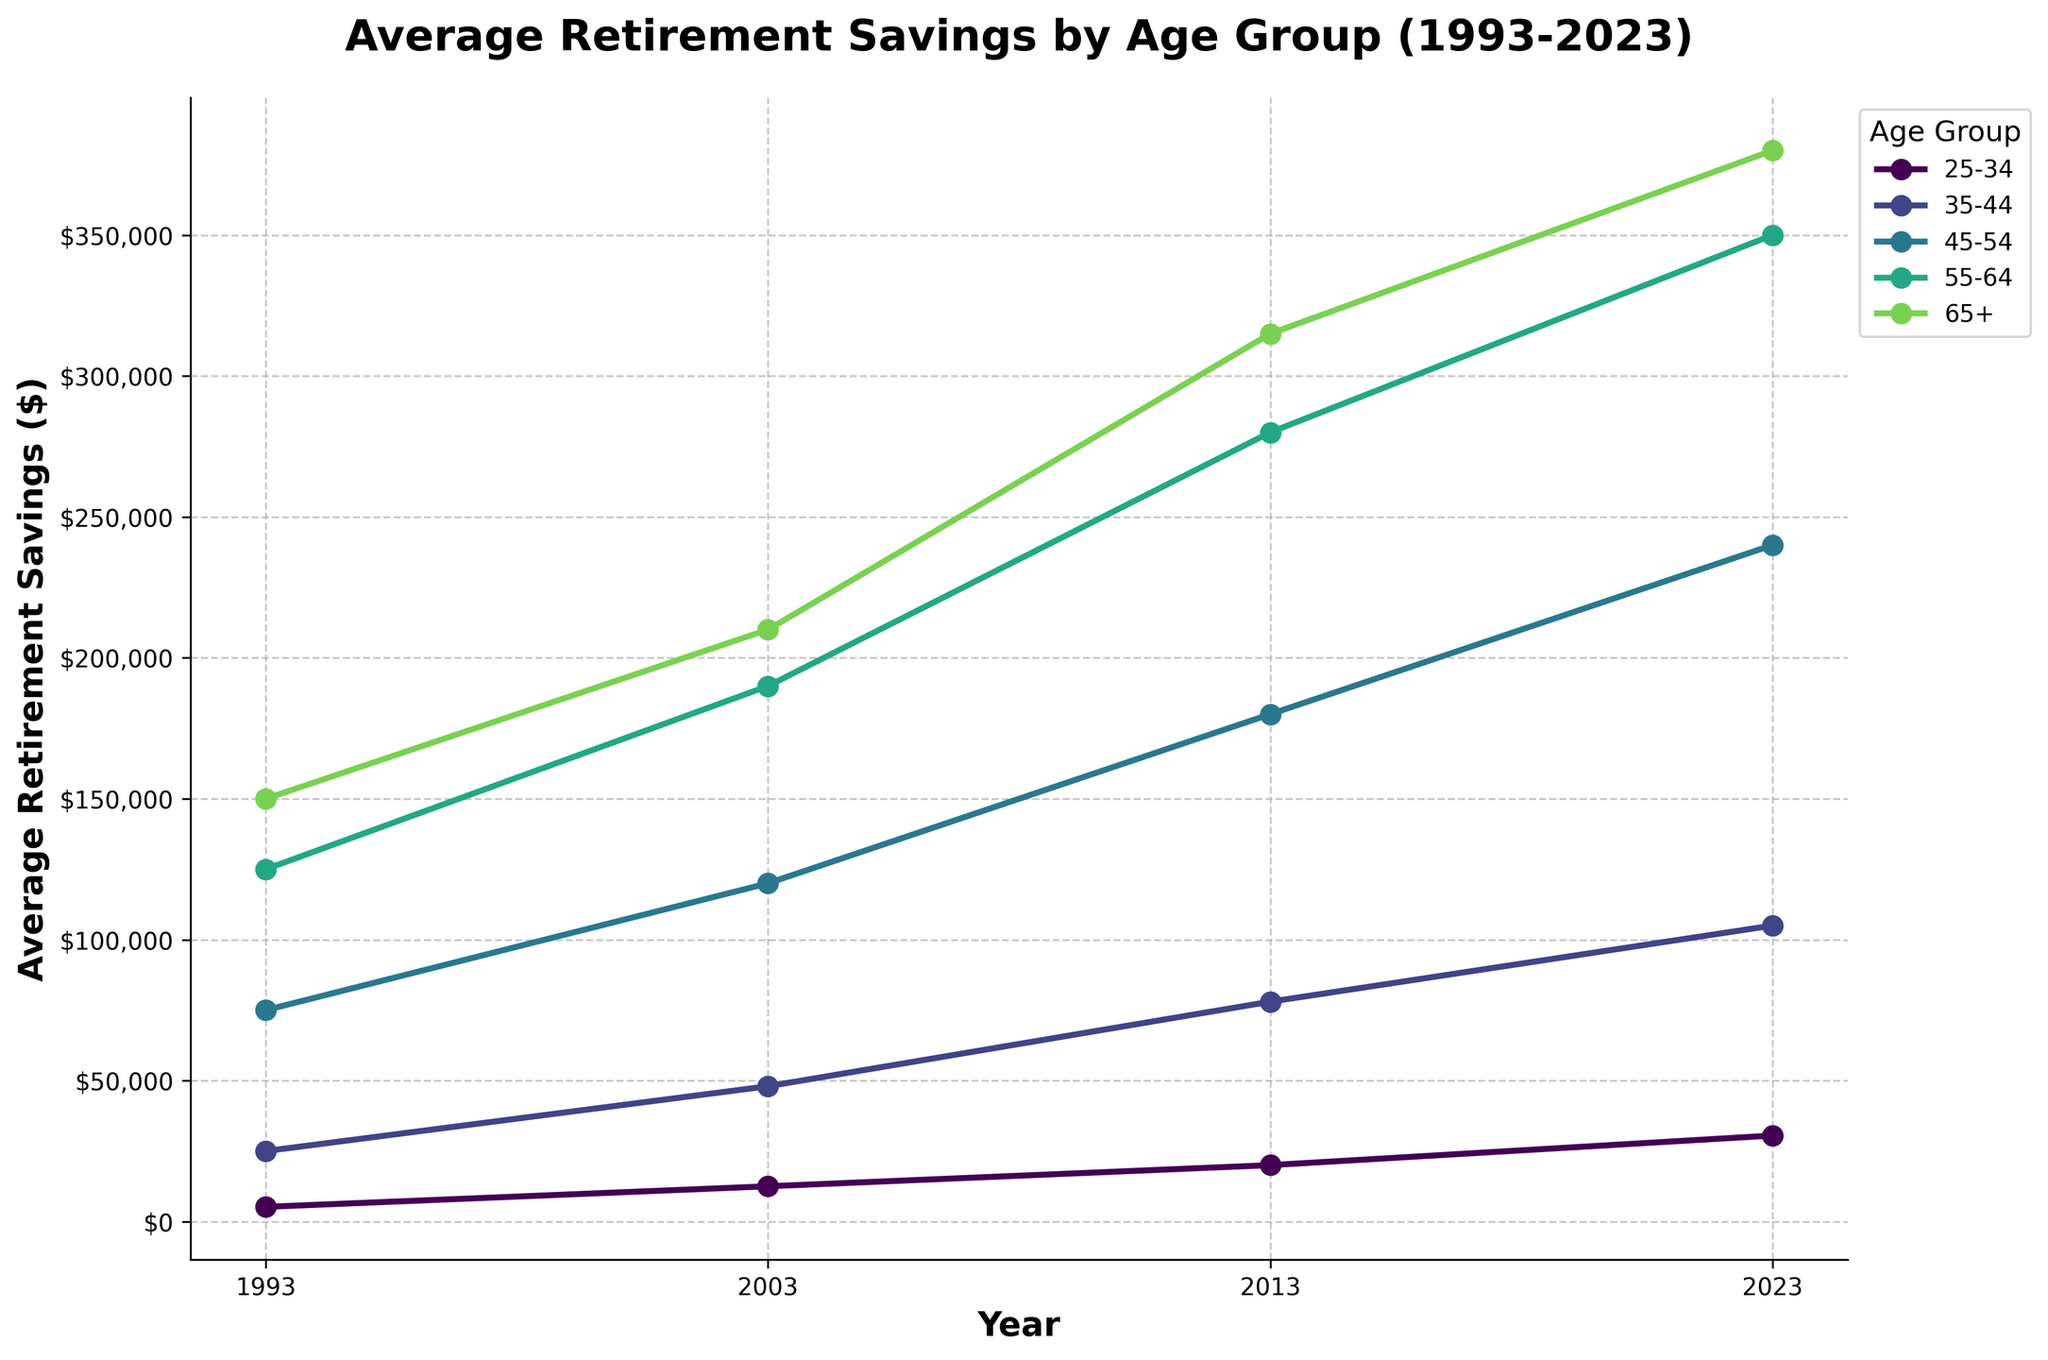What is the average retirement savings for the 55-64 age group in 2023? First, locate the 55-64 age group's data in 2023, which is represented by a point on the line chart. According to the table, this value is $350,000.
Answer: $350,000 Which age group had the highest average retirement savings in 1993? Check the 1993 data points for all age groups. The 65+ age group has the highest value of $150,000 among them.
Answer: 65+ What is the difference in average retirement savings for the 45-54 age group between 1993 and 2023? Identify the data points for the 45-54 age group in 1993 and 2023: $75,000 and $240,000 respectively. Calculate the difference: $240,000 - $75,000 = $165,000.
Answer: $165,000 Which age group shows the highest percentage increase in average savings from 1993 to 2023? Calculate the percentage increase for each age group using the formula: ((Value in 2023 - Value in 1993) / Value in 1993) * 100. The 25-34 age group shows ((30,500 - 5,200) / 5,200) * 100 = 486.54%.
Answer: 25-34 What is the trend of average retirement savings for the 35-44 age group from 1993 to 2023? Observe the line for the 35-44 age group from 1993 to 2023. The average retirement savings increase from $25,000 to $105,000. This indicates a consistent upward trend.
Answer: Upward Compare the average retirement savings of the 65+ age group in 2003 and 2023. Locate the 65+ age group data for 2003 and 2023, which are $210,000 and $380,000 respectively. 2023's savings are higher compared to 2003.
Answer: 2023 is higher By how much did average retirement savings for the 55-64 age group increase from 2003 to 2023? Find the values for the 55-64 age group in 2003 ($190,000) and in 2023 ($350,000). Subtract 2003 savings from 2023 savings: $350,000 - $190,000 = $160,000.
Answer: $160,000 Do younger age groups (25-34, 35-44) show a steeper increase in savings over the years compared to older ones (55-64, 65+)? Compare the slopes of the lines related to younger age groups with those of older age groups. Younger age groups like 25-34 and 35-44 have visibly steeper lines, indicating a faster rate of increase.
Answer: Yes What was the average retirement savings difference between the age groups 35-44 and 45-54 in 2013? Identify the 2013 data for 35-44 ($78,000) and 45-54 ($180,000), then subtract: $180,000 - $78,000 = $102,000.
Answer: $102,000 Which age group had the smallest absolute increase in average retirement savings from 1993 to 2023? Calculate the absolute increase for each age group. The smallest change is for the 65+ age group with $380,000 - $150,000 = $230,000.
Answer: 65+ 